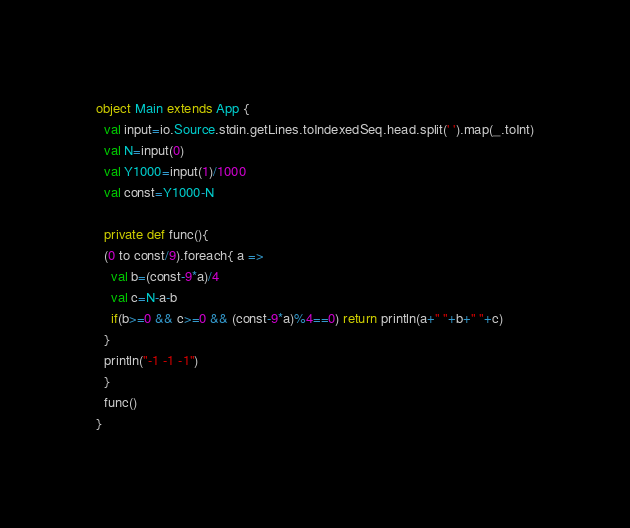<code> <loc_0><loc_0><loc_500><loc_500><_Scala_>object Main extends App {
  val input=io.Source.stdin.getLines.toIndexedSeq.head.split(' ').map(_.toInt)
  val N=input(0)
  val Y1000=input(1)/1000
  val const=Y1000-N  

  private def func(){
  (0 to const/9).foreach{ a =>
    val b=(const-9*a)/4
    val c=N-a-b
    if(b>=0 && c>=0 && (const-9*a)%4==0) return println(a+" "+b+" "+c)
  }
  println("-1 -1 -1")
  }
  func()
}
</code> 